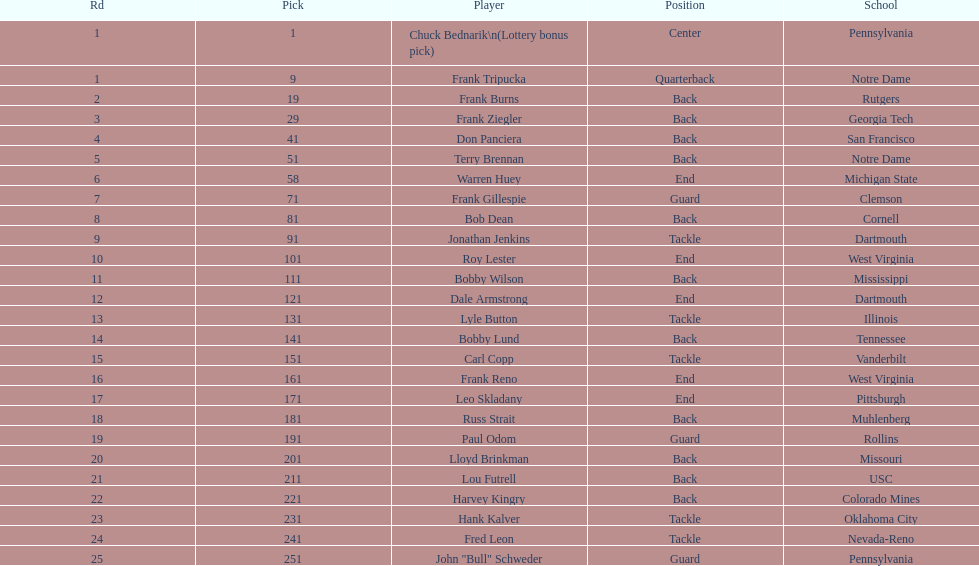After bob dean, which participant was drafted by the team? Jonathan Jenkins. 